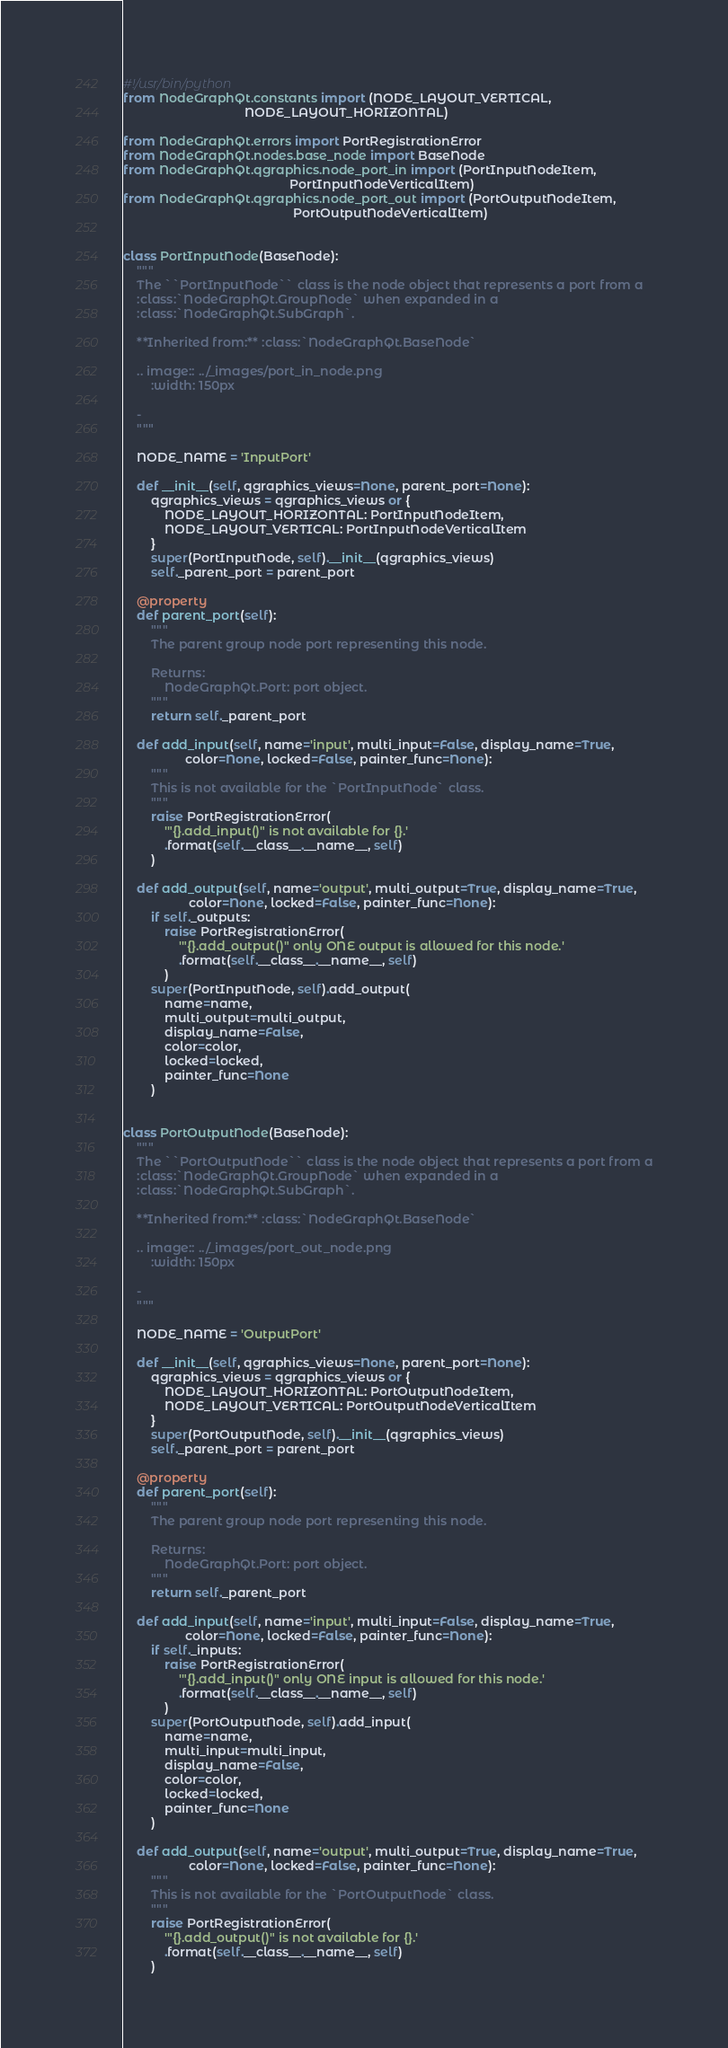<code> <loc_0><loc_0><loc_500><loc_500><_Python_>#!/usr/bin/python
from NodeGraphQt.constants import (NODE_LAYOUT_VERTICAL,
                                   NODE_LAYOUT_HORIZONTAL)

from NodeGraphQt.errors import PortRegistrationError
from NodeGraphQt.nodes.base_node import BaseNode
from NodeGraphQt.qgraphics.node_port_in import (PortInputNodeItem,
                                                PortInputNodeVerticalItem)
from NodeGraphQt.qgraphics.node_port_out import (PortOutputNodeItem,
                                                 PortOutputNodeVerticalItem)


class PortInputNode(BaseNode):
    """
    The ``PortInputNode`` class is the node object that represents a port from a
    :class:`NodeGraphQt.GroupNode` when expanded in a
    :class:`NodeGraphQt.SubGraph`.

    **Inherited from:** :class:`NodeGraphQt.BaseNode`

    .. image:: ../_images/port_in_node.png
        :width: 150px

    -
    """

    NODE_NAME = 'InputPort'

    def __init__(self, qgraphics_views=None, parent_port=None):
        qgraphics_views = qgraphics_views or {
            NODE_LAYOUT_HORIZONTAL: PortInputNodeItem,
            NODE_LAYOUT_VERTICAL: PortInputNodeVerticalItem
        }
        super(PortInputNode, self).__init__(qgraphics_views)
        self._parent_port = parent_port

    @property
    def parent_port(self):
        """
        The parent group node port representing this node.

        Returns:
            NodeGraphQt.Port: port object.
        """
        return self._parent_port

    def add_input(self, name='input', multi_input=False, display_name=True,
                  color=None, locked=False, painter_func=None):
        """
        This is not available for the `PortInputNode` class.
        """
        raise PortRegistrationError(
            '"{}.add_input()" is not available for {}.'
            .format(self.__class__.__name__, self)
        )

    def add_output(self, name='output', multi_output=True, display_name=True,
                   color=None, locked=False, painter_func=None):
        if self._outputs:
            raise PortRegistrationError(
                '"{}.add_output()" only ONE output is allowed for this node.'
                .format(self.__class__.__name__, self)
            )
        super(PortInputNode, self).add_output(
            name=name,
            multi_output=multi_output,
            display_name=False,
            color=color,
            locked=locked,
            painter_func=None
        )


class PortOutputNode(BaseNode):
    """
    The ``PortOutputNode`` class is the node object that represents a port from a
    :class:`NodeGraphQt.GroupNode` when expanded in a
    :class:`NodeGraphQt.SubGraph`.

    **Inherited from:** :class:`NodeGraphQt.BaseNode`

    .. image:: ../_images/port_out_node.png
        :width: 150px

    -
    """

    NODE_NAME = 'OutputPort'

    def __init__(self, qgraphics_views=None, parent_port=None):
        qgraphics_views = qgraphics_views or {
            NODE_LAYOUT_HORIZONTAL: PortOutputNodeItem,
            NODE_LAYOUT_VERTICAL: PortOutputNodeVerticalItem
        }
        super(PortOutputNode, self).__init__(qgraphics_views)
        self._parent_port = parent_port

    @property
    def parent_port(self):
        """
        The parent group node port representing this node.

        Returns:
            NodeGraphQt.Port: port object.
        """
        return self._parent_port

    def add_input(self, name='input', multi_input=False, display_name=True,
                  color=None, locked=False, painter_func=None):
        if self._inputs:
            raise PortRegistrationError(
                '"{}.add_input()" only ONE input is allowed for this node.'
                .format(self.__class__.__name__, self)
            )
        super(PortOutputNode, self).add_input(
            name=name,
            multi_input=multi_input,
            display_name=False,
            color=color,
            locked=locked,
            painter_func=None
        )

    def add_output(self, name='output', multi_output=True, display_name=True,
                   color=None, locked=False, painter_func=None):
        """
        This is not available for the `PortOutputNode` class.
        """
        raise PortRegistrationError(
            '"{}.add_output()" is not available for {}.'
            .format(self.__class__.__name__, self)
        )
</code> 